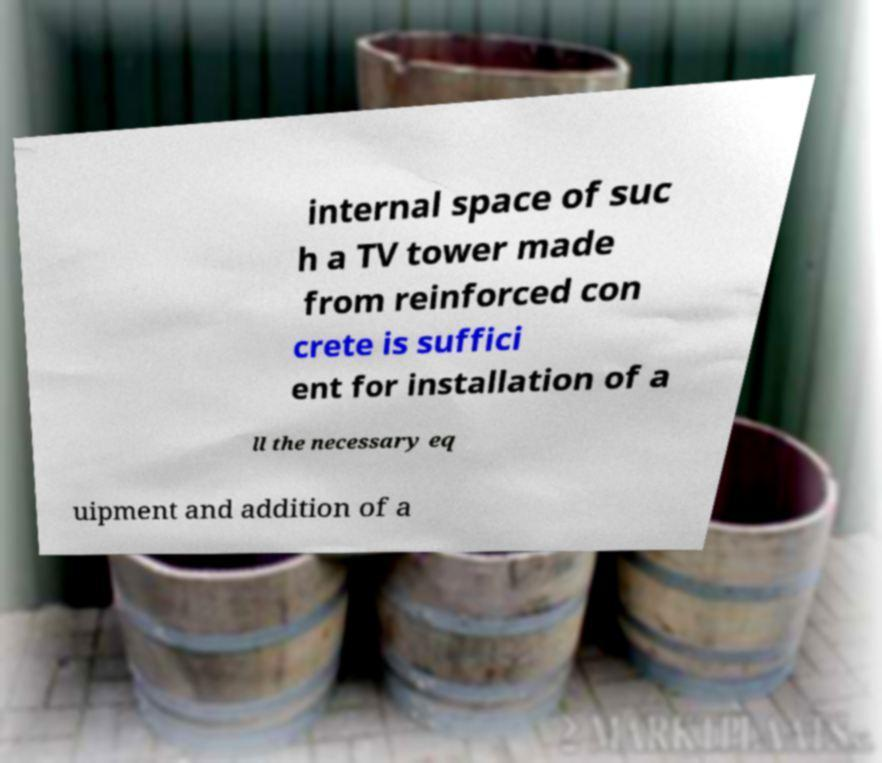Can you read and provide the text displayed in the image?This photo seems to have some interesting text. Can you extract and type it out for me? internal space of suc h a TV tower made from reinforced con crete is suffici ent for installation of a ll the necessary eq uipment and addition of a 